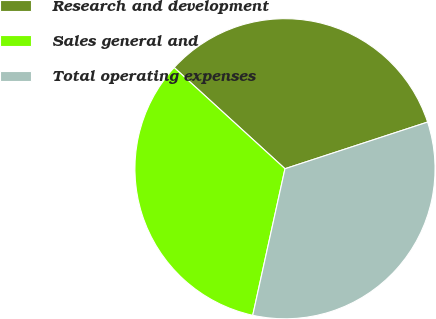<chart> <loc_0><loc_0><loc_500><loc_500><pie_chart><fcel>Research and development<fcel>Sales general and<fcel>Total operating expenses<nl><fcel>33.19%<fcel>33.33%<fcel>33.48%<nl></chart> 